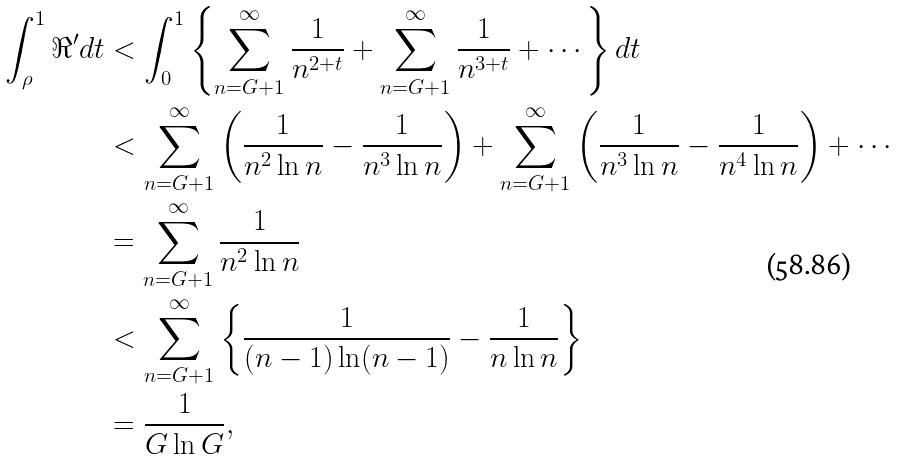<formula> <loc_0><loc_0><loc_500><loc_500>\int _ { \rho } ^ { 1 } \Re ^ { \prime } d t & < \int _ { 0 } ^ { 1 } \left \{ \sum _ { n = G + 1 } ^ { \infty } \frac { 1 } { n ^ { 2 + t } } + \sum _ { n = G + 1 } ^ { \infty } \frac { 1 } { n ^ { 3 + t } } + \cdots \right \} d t \\ & < \sum _ { n = G + 1 } ^ { \infty } \left ( \frac { 1 } { n ^ { 2 } \ln n } - \frac { 1 } { n ^ { 3 } \ln n } \right ) + \sum _ { n = G + 1 } ^ { \infty } \left ( \frac { 1 } { n ^ { 3 } \ln n } - \frac { 1 } { n ^ { 4 } \ln n } \right ) + \cdots \\ & = \sum _ { n = G + 1 } ^ { \infty } \frac { 1 } { n ^ { 2 } \ln n } \\ & < \sum _ { n = G + 1 } ^ { \infty } \left \{ \frac { 1 } { ( n - 1 ) \ln ( n - 1 ) } - \frac { 1 } { n \ln n } \right \} \\ & = \frac { 1 } { G \ln G } ,</formula> 